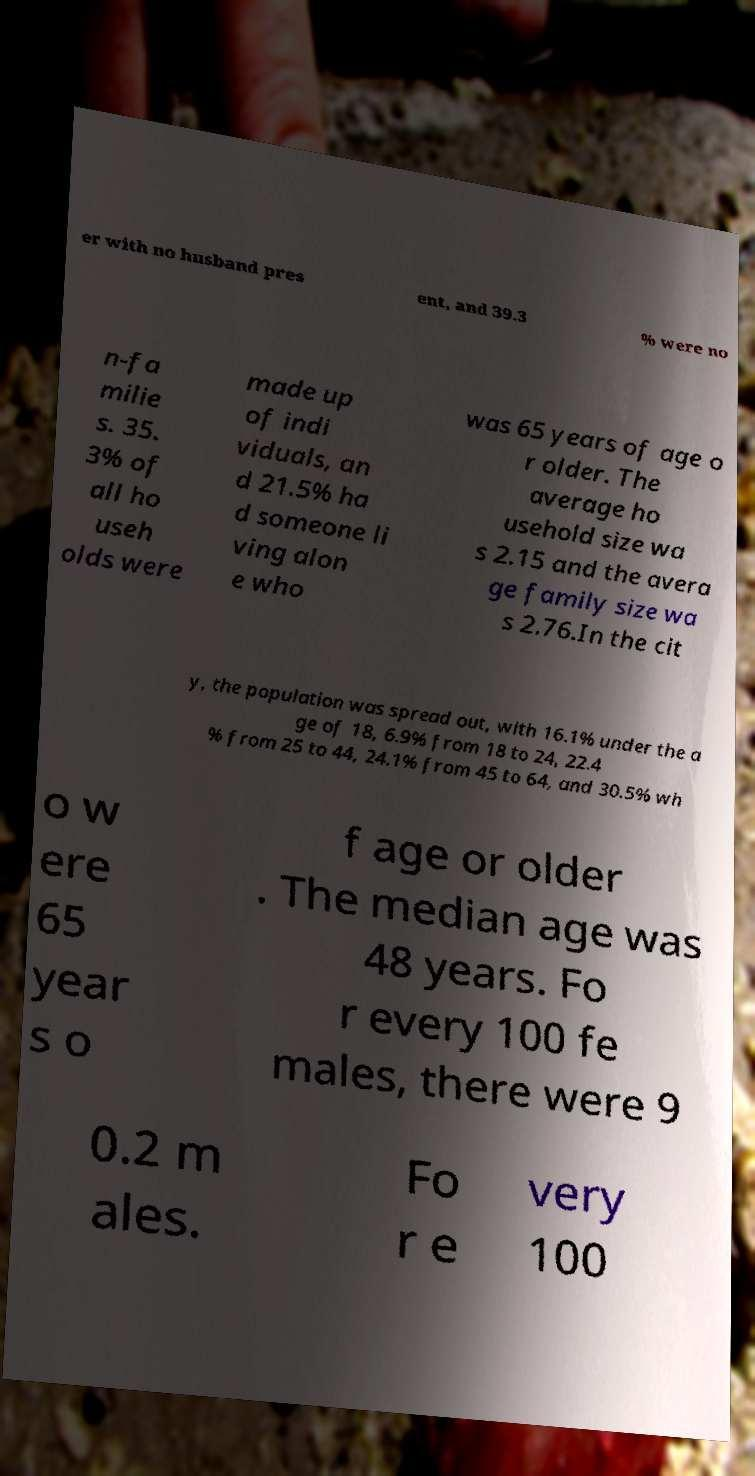There's text embedded in this image that I need extracted. Can you transcribe it verbatim? er with no husband pres ent, and 39.3 % were no n-fa milie s. 35. 3% of all ho useh olds were made up of indi viduals, an d 21.5% ha d someone li ving alon e who was 65 years of age o r older. The average ho usehold size wa s 2.15 and the avera ge family size wa s 2.76.In the cit y, the population was spread out, with 16.1% under the a ge of 18, 6.9% from 18 to 24, 22.4 % from 25 to 44, 24.1% from 45 to 64, and 30.5% wh o w ere 65 year s o f age or older . The median age was 48 years. Fo r every 100 fe males, there were 9 0.2 m ales. Fo r e very 100 